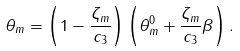Convert formula to latex. <formula><loc_0><loc_0><loc_500><loc_500>\theta _ { m } = \left ( 1 - \frac { \zeta _ { m } } { c _ { 3 } } \right ) \left ( \theta ^ { 0 } _ { m } + \frac { \zeta _ { m } } { c _ { 3 } } \beta \right ) .</formula> 